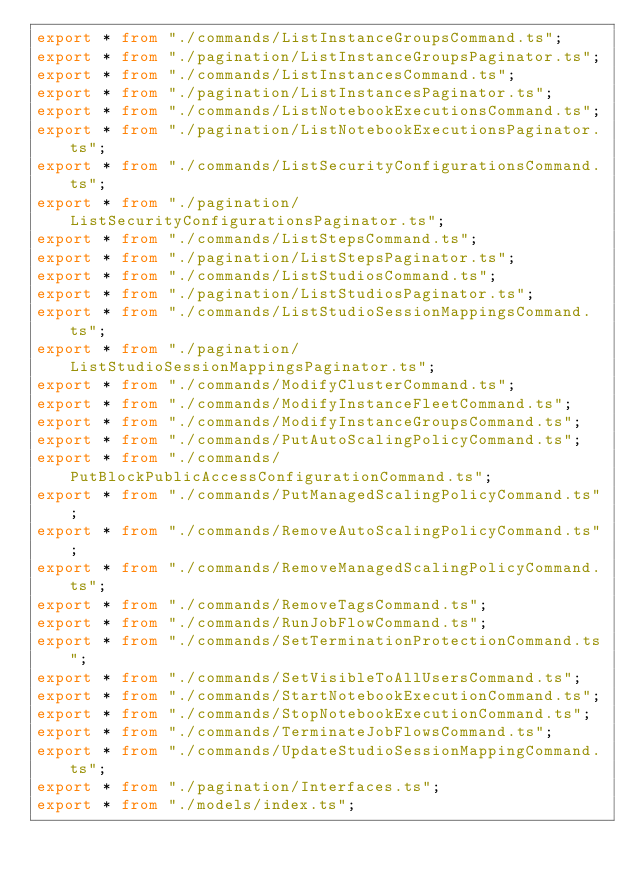<code> <loc_0><loc_0><loc_500><loc_500><_TypeScript_>export * from "./commands/ListInstanceGroupsCommand.ts";
export * from "./pagination/ListInstanceGroupsPaginator.ts";
export * from "./commands/ListInstancesCommand.ts";
export * from "./pagination/ListInstancesPaginator.ts";
export * from "./commands/ListNotebookExecutionsCommand.ts";
export * from "./pagination/ListNotebookExecutionsPaginator.ts";
export * from "./commands/ListSecurityConfigurationsCommand.ts";
export * from "./pagination/ListSecurityConfigurationsPaginator.ts";
export * from "./commands/ListStepsCommand.ts";
export * from "./pagination/ListStepsPaginator.ts";
export * from "./commands/ListStudiosCommand.ts";
export * from "./pagination/ListStudiosPaginator.ts";
export * from "./commands/ListStudioSessionMappingsCommand.ts";
export * from "./pagination/ListStudioSessionMappingsPaginator.ts";
export * from "./commands/ModifyClusterCommand.ts";
export * from "./commands/ModifyInstanceFleetCommand.ts";
export * from "./commands/ModifyInstanceGroupsCommand.ts";
export * from "./commands/PutAutoScalingPolicyCommand.ts";
export * from "./commands/PutBlockPublicAccessConfigurationCommand.ts";
export * from "./commands/PutManagedScalingPolicyCommand.ts";
export * from "./commands/RemoveAutoScalingPolicyCommand.ts";
export * from "./commands/RemoveManagedScalingPolicyCommand.ts";
export * from "./commands/RemoveTagsCommand.ts";
export * from "./commands/RunJobFlowCommand.ts";
export * from "./commands/SetTerminationProtectionCommand.ts";
export * from "./commands/SetVisibleToAllUsersCommand.ts";
export * from "./commands/StartNotebookExecutionCommand.ts";
export * from "./commands/StopNotebookExecutionCommand.ts";
export * from "./commands/TerminateJobFlowsCommand.ts";
export * from "./commands/UpdateStudioSessionMappingCommand.ts";
export * from "./pagination/Interfaces.ts";
export * from "./models/index.ts";
</code> 